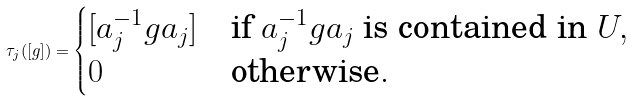Convert formula to latex. <formula><loc_0><loc_0><loc_500><loc_500>\tau _ { j } ( [ g ] ) = \begin{cases} [ a _ { j } ^ { - 1 } g a _ { j } ] & \text {if } a _ { j } ^ { - 1 } g a _ { j } \text { is contained in } U , \\ 0 & \text {otherwise} . \end{cases}</formula> 